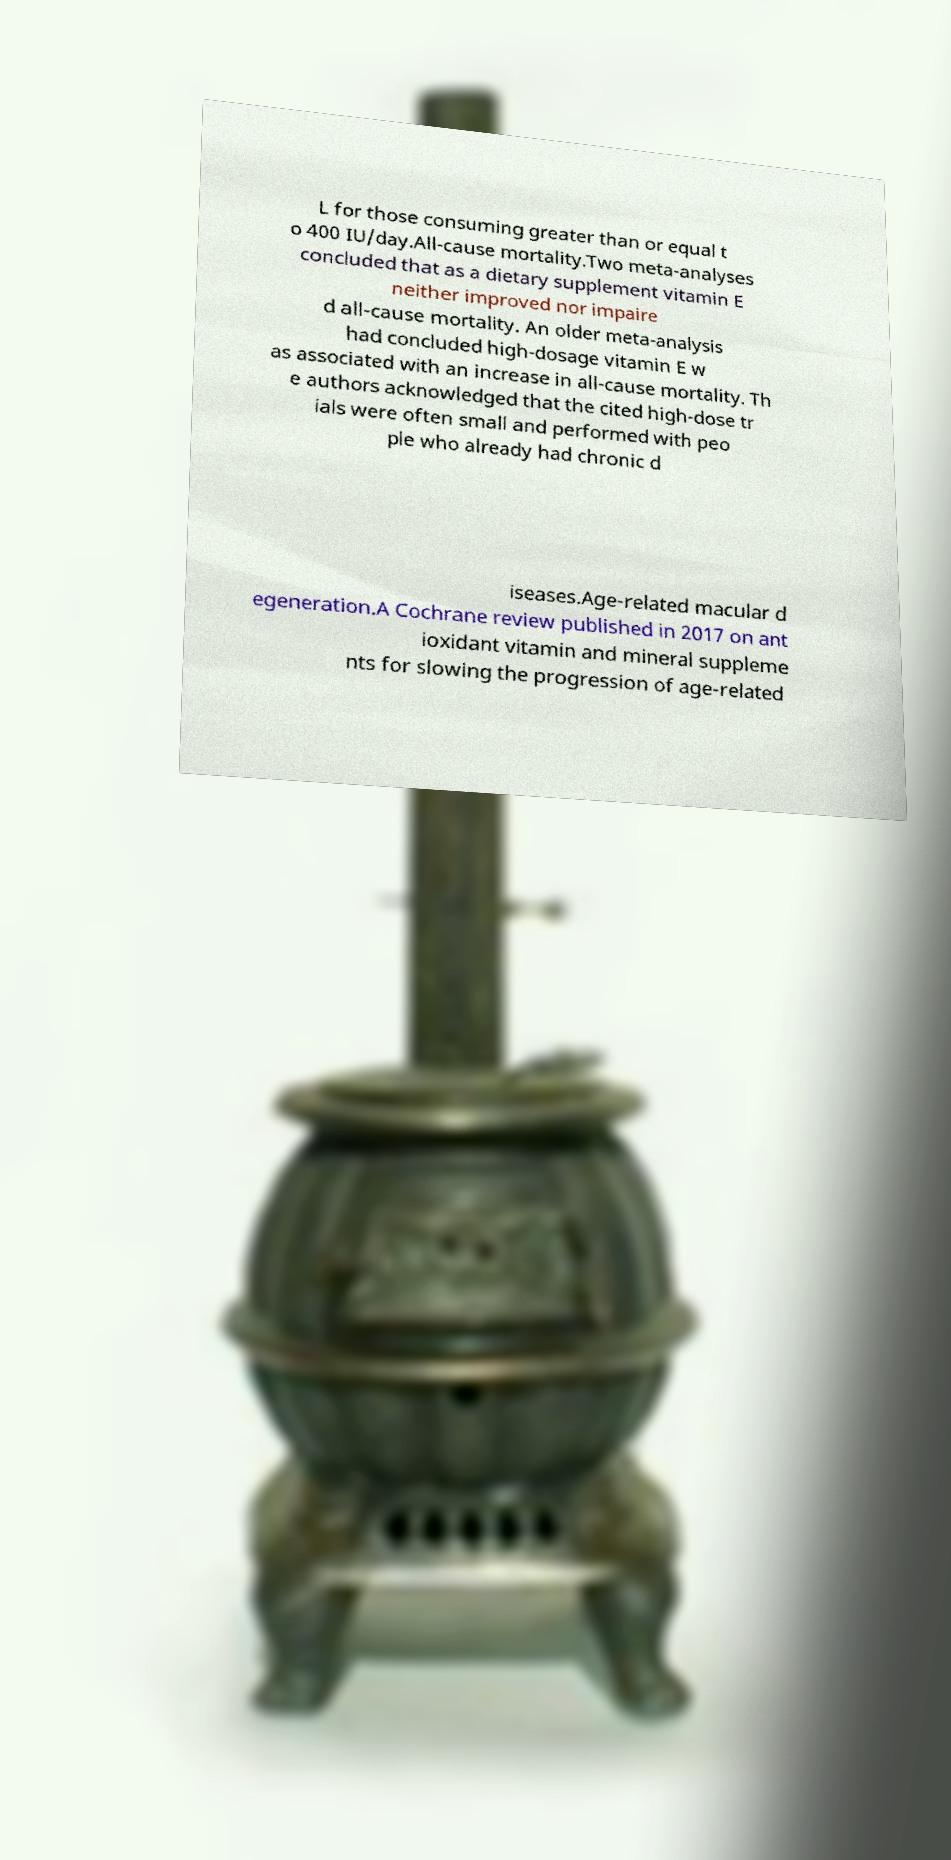Could you assist in decoding the text presented in this image and type it out clearly? L for those consuming greater than or equal t o 400 IU/day.All-cause mortality.Two meta-analyses concluded that as a dietary supplement vitamin E neither improved nor impaire d all-cause mortality. An older meta-analysis had concluded high-dosage vitamin E w as associated with an increase in all-cause mortality. Th e authors acknowledged that the cited high-dose tr ials were often small and performed with peo ple who already had chronic d iseases.Age-related macular d egeneration.A Cochrane review published in 2017 on ant ioxidant vitamin and mineral suppleme nts for slowing the progression of age-related 